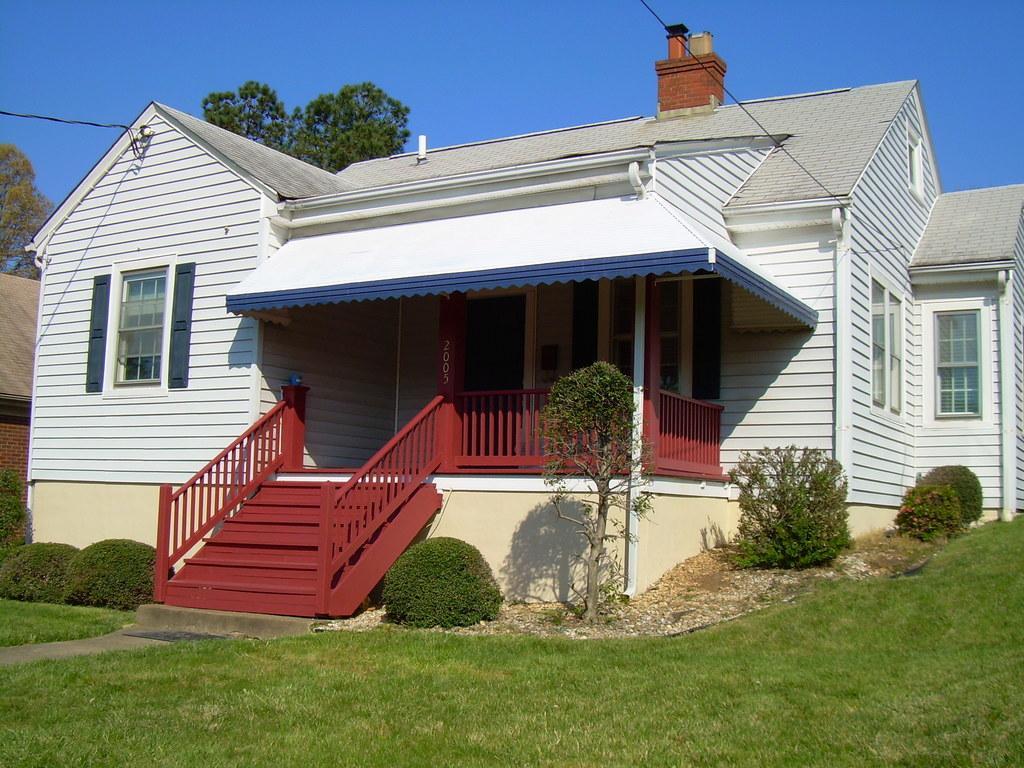Please provide a concise description of this image. In this picture we can see there are houses and in front of the house there are plants and grass and behind the house there are cables, trees and a sky. 